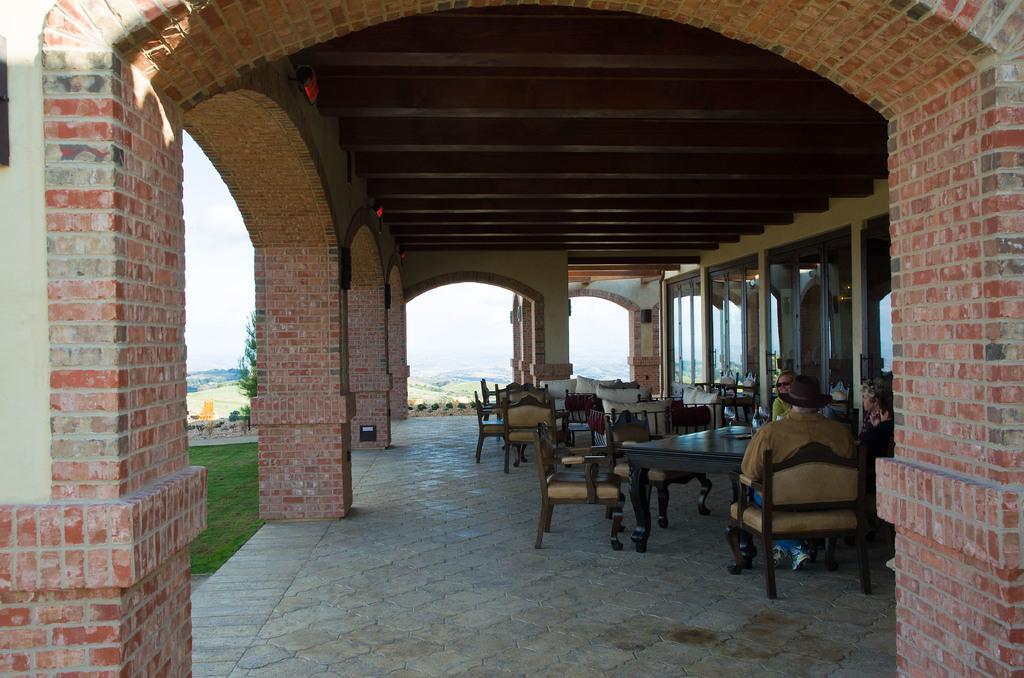Describe this image in one or two sentences. In this picture we can see a building with a brick wall, and in the left there are few people sitting in front of a table. In the backdrop we have mountains and clear sky. 